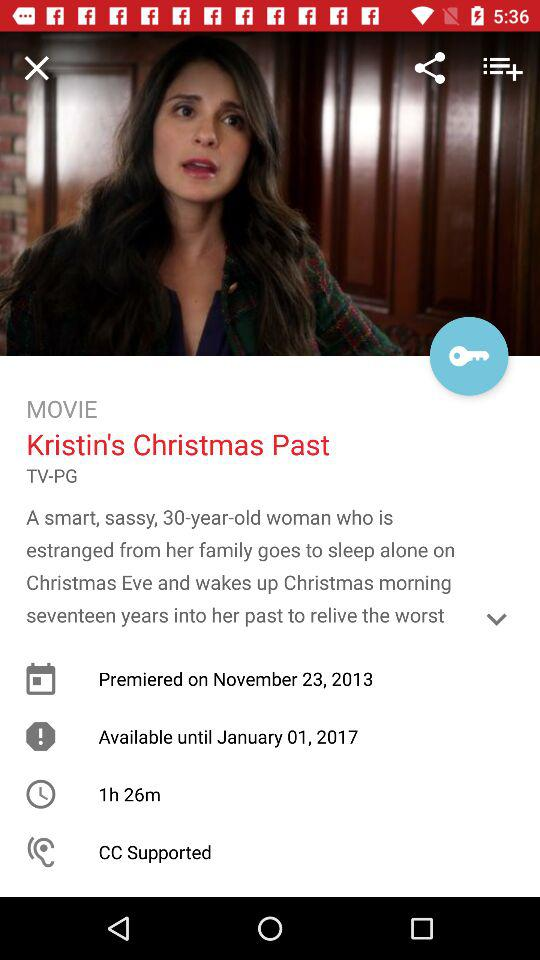How long is the movie? The movie is 1 hour 26 minutes long. 